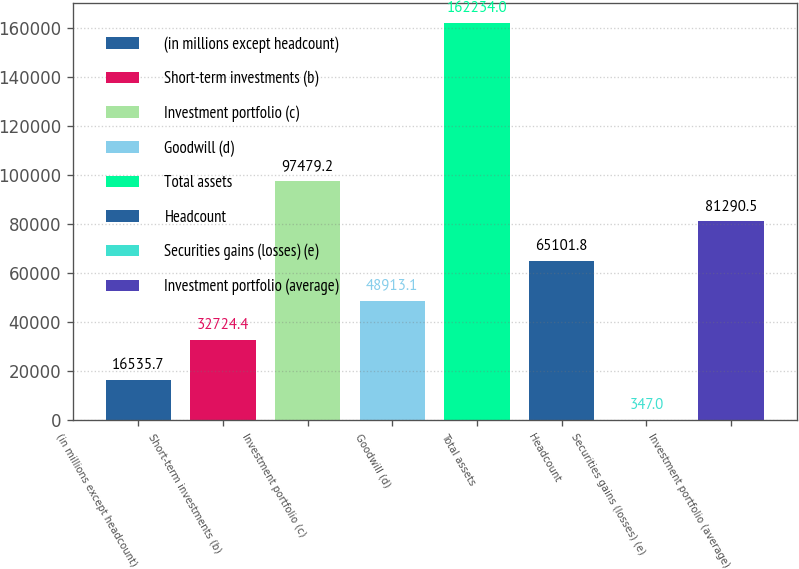<chart> <loc_0><loc_0><loc_500><loc_500><bar_chart><fcel>(in millions except headcount)<fcel>Short-term investments (b)<fcel>Investment portfolio (c)<fcel>Goodwill (d)<fcel>Total assets<fcel>Headcount<fcel>Securities gains (losses) (e)<fcel>Investment portfolio (average)<nl><fcel>16535.7<fcel>32724.4<fcel>97479.2<fcel>48913.1<fcel>162234<fcel>65101.8<fcel>347<fcel>81290.5<nl></chart> 